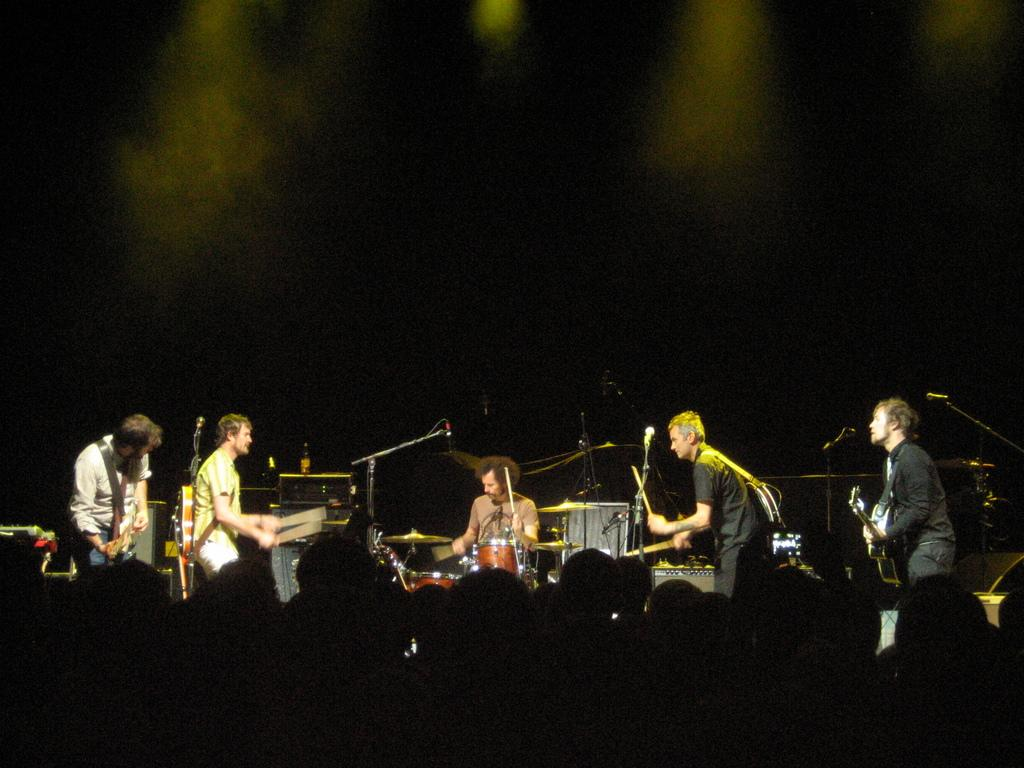How many persons are in the image? There are persons in the image. What are the persons doing in the image? The persons are playing musical instruments. What equipment is present in the image to amplify sound? There are microphones (mikes) in the image. Are there any pets involved in the argument in the image? There is no argument or pets present in the image; the persons are playing musical instruments. 